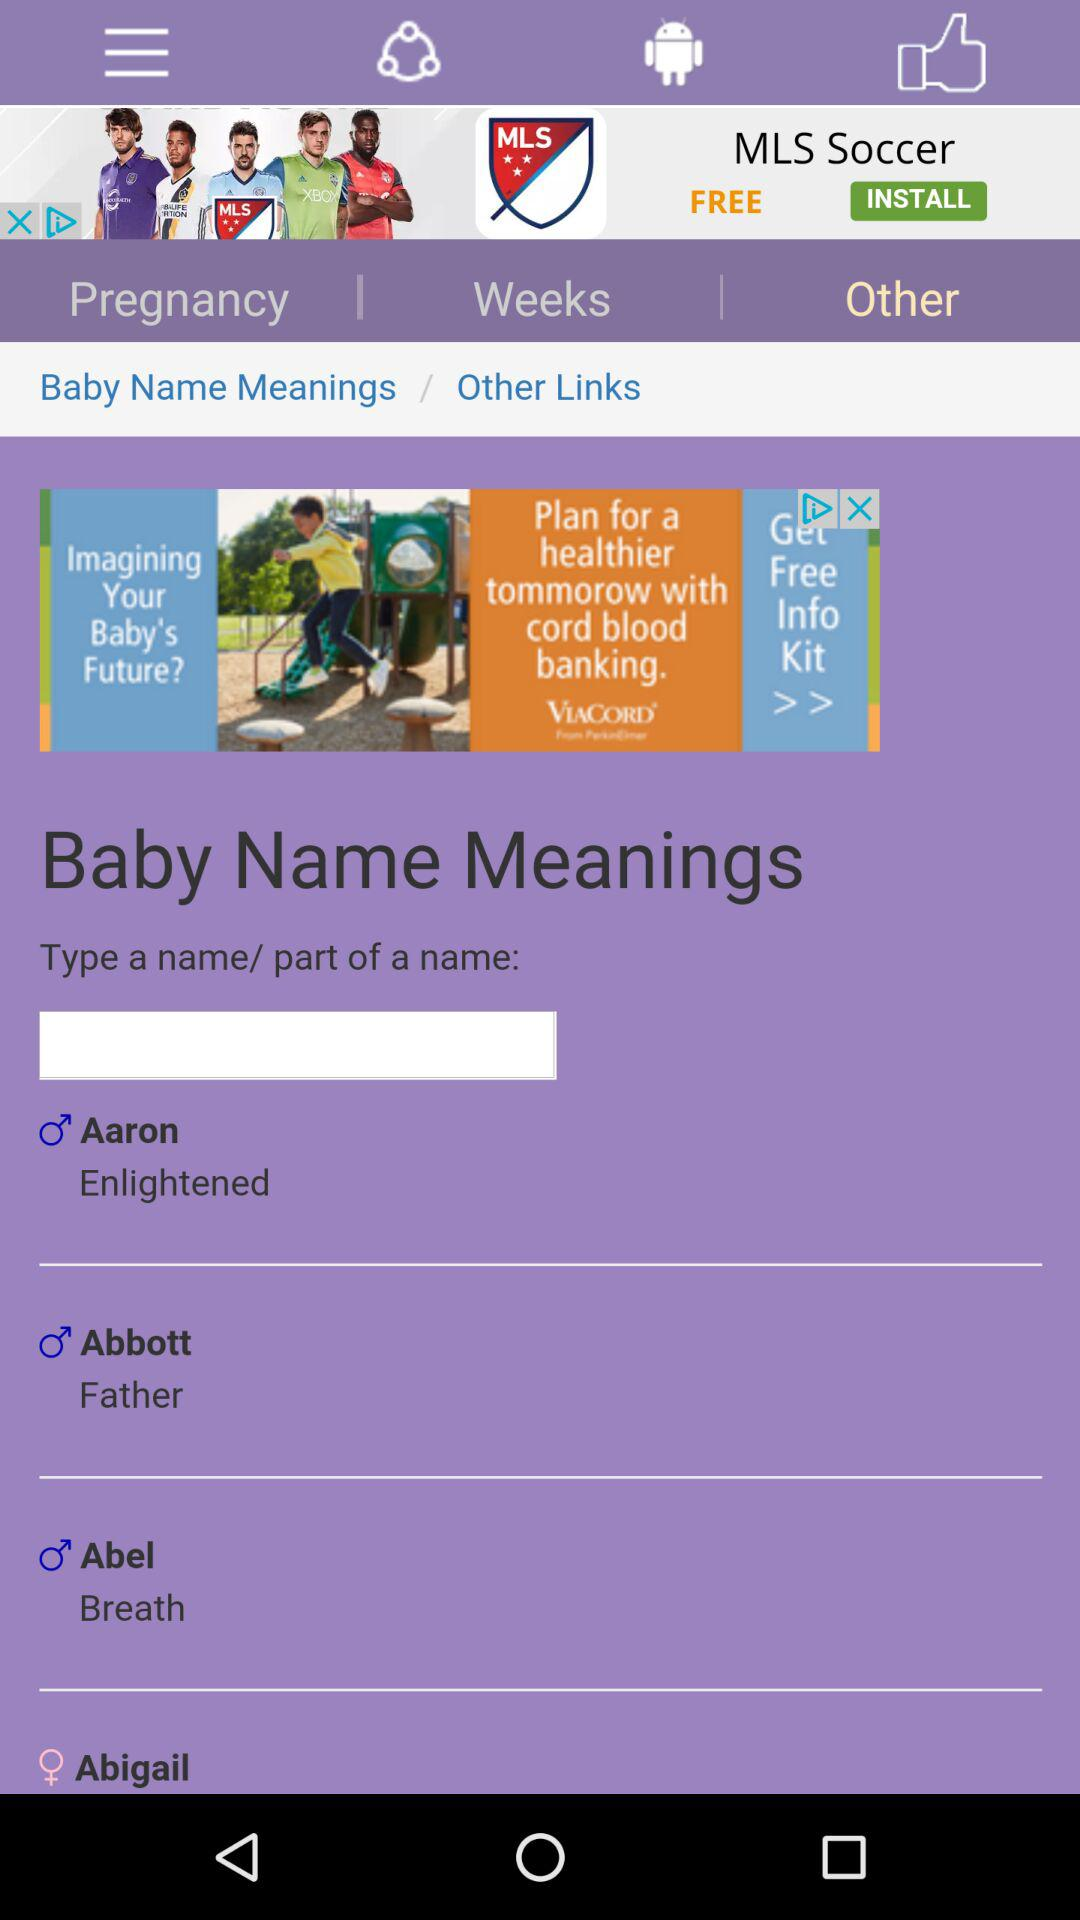What is the meaning of the baby name Aaron? The meaning of the baby name Aaron is "Enlightened". 